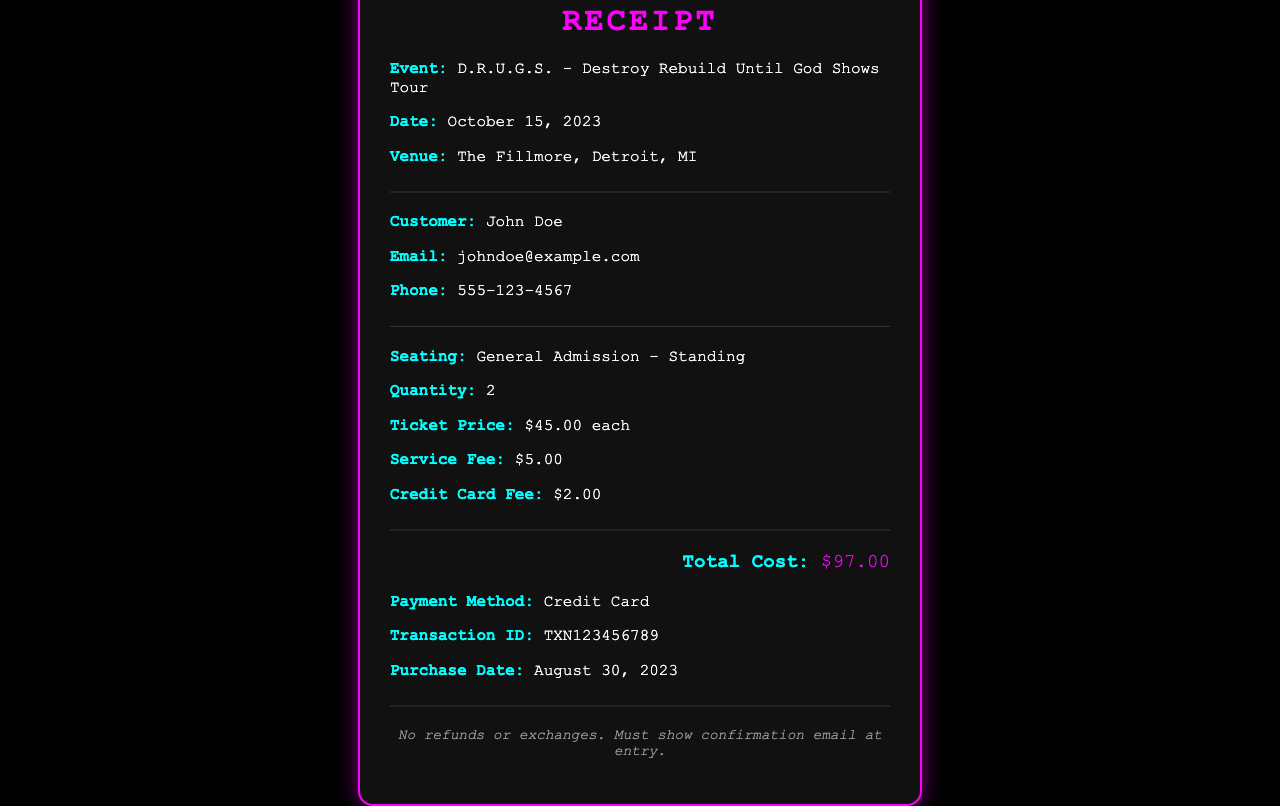What is the event name? The event name is explicitly stated in the receipt, which describes the particular concert.
Answer: D.R.U.G.S. - Destroy Rebuild Until God Shows Tour What is the date of the concert? The date of the concert is clearly indicated in the receipt's event section.
Answer: October 15, 2023 How many tickets were purchased? The receipt specifies the quantity of tickets bought by the customer.
Answer: 2 What is the total cost of the tickets? The total cost is summarized at the bottom of the receipt, representing the aggregate of ticket prices, additional fees, etc.
Answer: $97.00 What type of seating was selected? The receipt provides seating details under the seating section.
Answer: General Admission - Standing What was the service fee? The service fee is explicitly listed in the fees breakdown of the receipt.
Answer: $5.00 What payment method was used? The method of payment is specified in the payment section of the receipt.
Answer: Credit Card What is the transaction ID? The transaction ID is provided as a unique identifier for the purchase on the receipt.
Answer: TXN123456789 What should customers show at entry? The document includes instructions for customers regarding entry requirements.
Answer: confirmation email 